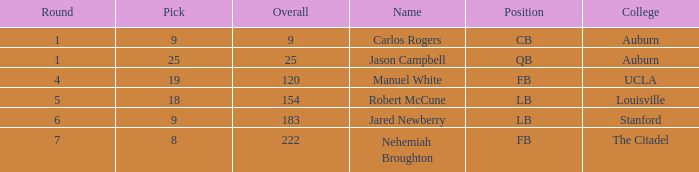Which college had an overall pick of 9? Auburn. 